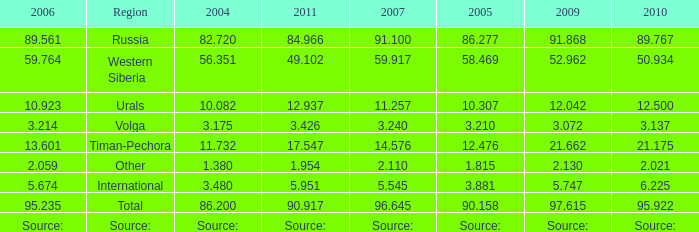What is the 2005 Lukoil oil prodroduction when in 2007 oil production 5.545 million tonnes? 3.881. 